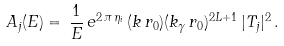Convert formula to latex. <formula><loc_0><loc_0><loc_500><loc_500>A _ { j } ( E ) = \, \frac { 1 } { E } \, e ^ { 2 \, \pi \, \eta _ { i } } \, ( k \, r _ { 0 } ) ( k _ { \gamma } \, r _ { 0 } ) ^ { 2 L + 1 } \, | T _ { j } | ^ { 2 } \, .</formula> 